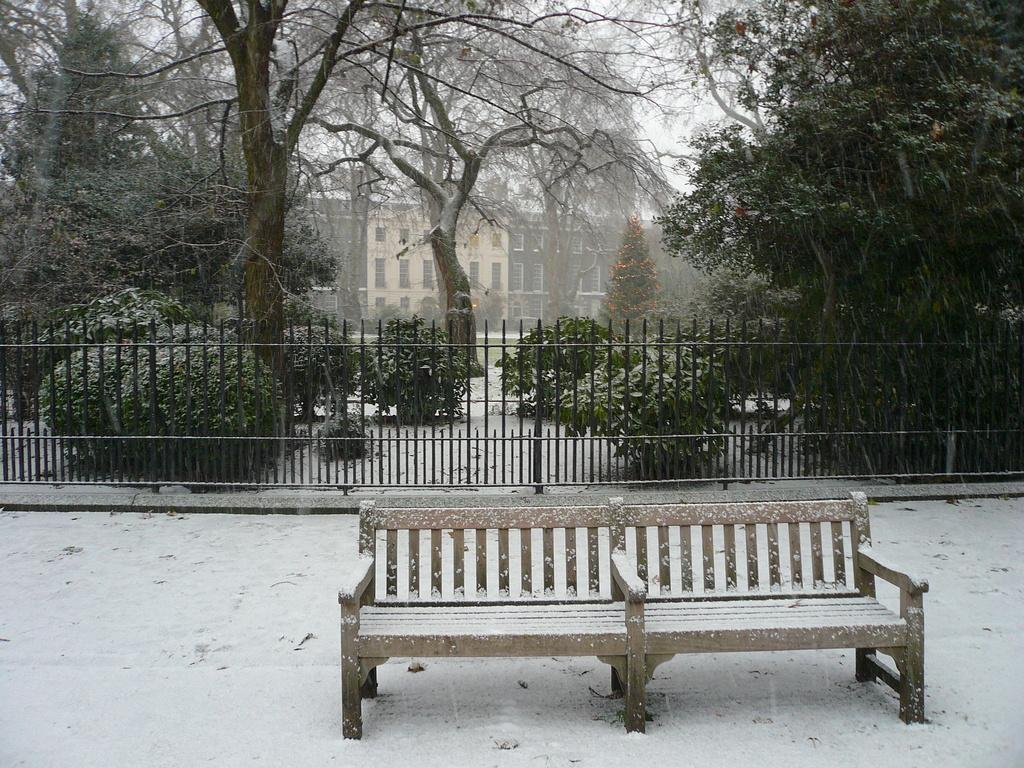Could you give a brief overview of what you see in this image? In this image there is a pavement, on that there is a bench, in the background there is a trailing, plants, trees and buildings. 